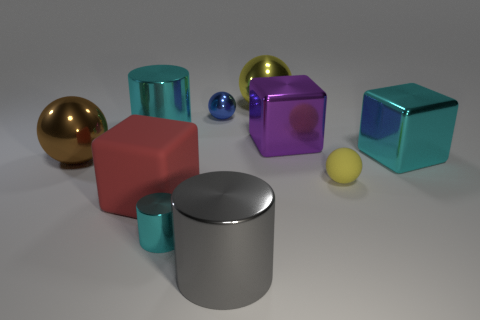Can you describe the colors and shapes of the objects in the image? Certainly! The image shows a collection of geometric shapes. There's a large brown sphere, a cyan cylinder, and a red cube, along with a purple, a teal, and a silver cube. Additionally, there's a tiny blue sphere and a small yellow sphere, as well as a smaller cyan cylinder. 